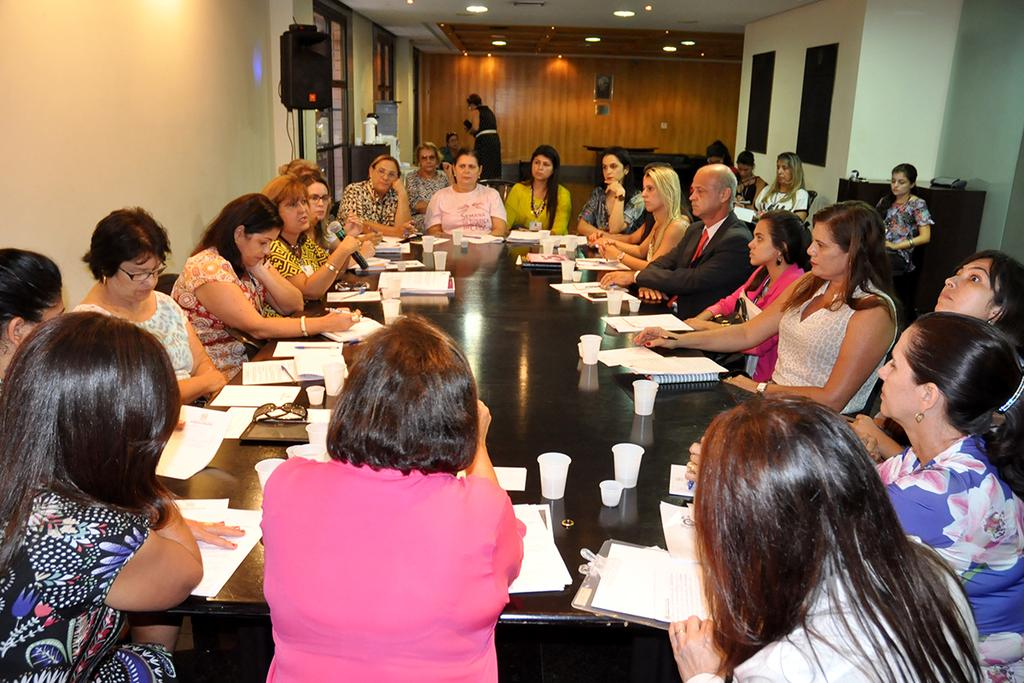What is happening in the image? There is a group of people in the image, and they are sitting on chairs. How are the chairs arranged in the image? The chairs are arranged around a table. What can be seen on the table in the image? There are papers and glasses on the table. What is the color of the wall on the right side of the image? The wall on the right side of the image is white. What type of beef is being served at the holiday party in the image? There is no holiday party or beef present in the image. What type of car is parked in front of the building in the image? There is no car present in the image. 